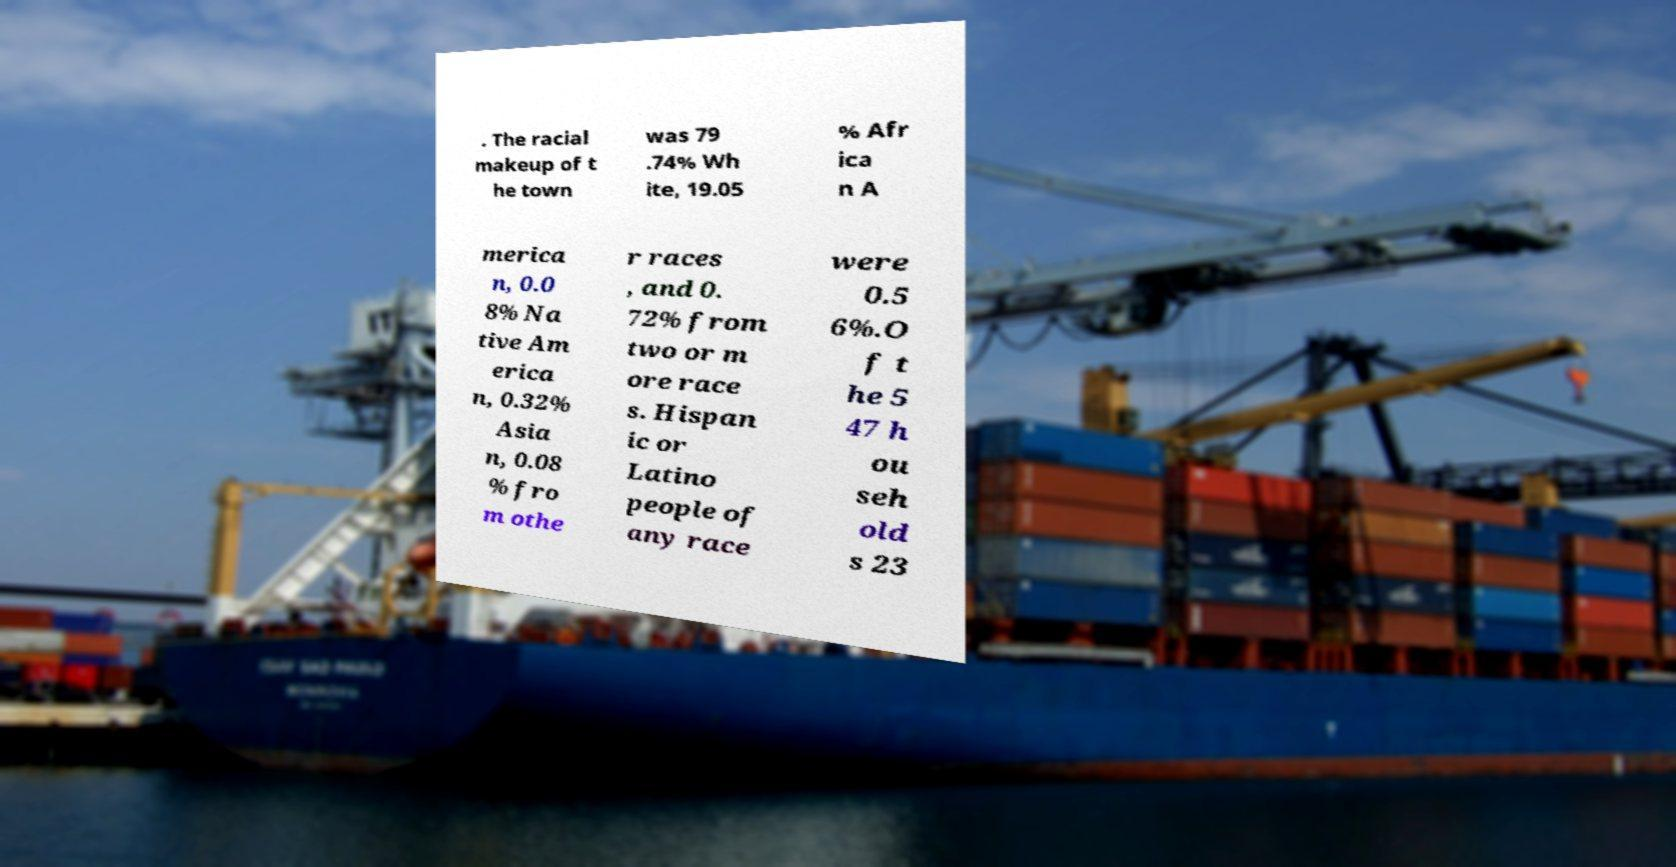There's text embedded in this image that I need extracted. Can you transcribe it verbatim? . The racial makeup of t he town was 79 .74% Wh ite, 19.05 % Afr ica n A merica n, 0.0 8% Na tive Am erica n, 0.32% Asia n, 0.08 % fro m othe r races , and 0. 72% from two or m ore race s. Hispan ic or Latino people of any race were 0.5 6%.O f t he 5 47 h ou seh old s 23 